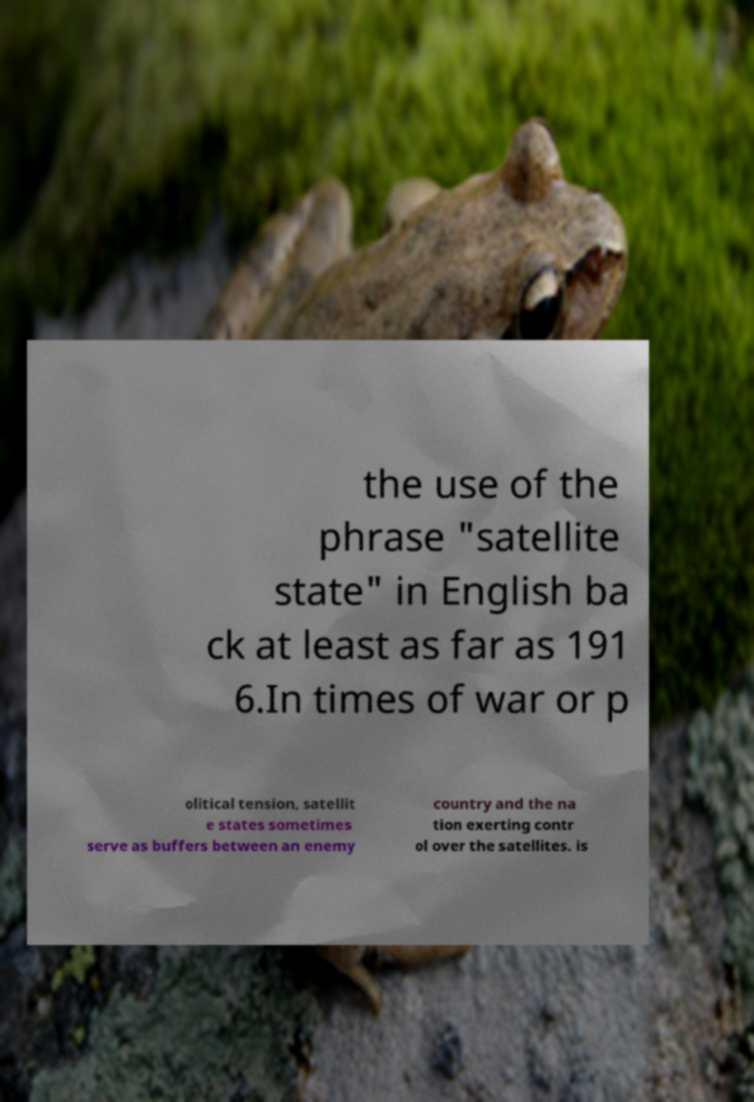Could you extract and type out the text from this image? the use of the phrase "satellite state" in English ba ck at least as far as 191 6.In times of war or p olitical tension, satellit e states sometimes serve as buffers between an enemy country and the na tion exerting contr ol over the satellites. is 